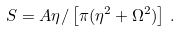Convert formula to latex. <formula><loc_0><loc_0><loc_500><loc_500>S = A \eta / \left [ \pi ( \eta ^ { 2 } + \Omega ^ { 2 } ) \right ] \, .</formula> 